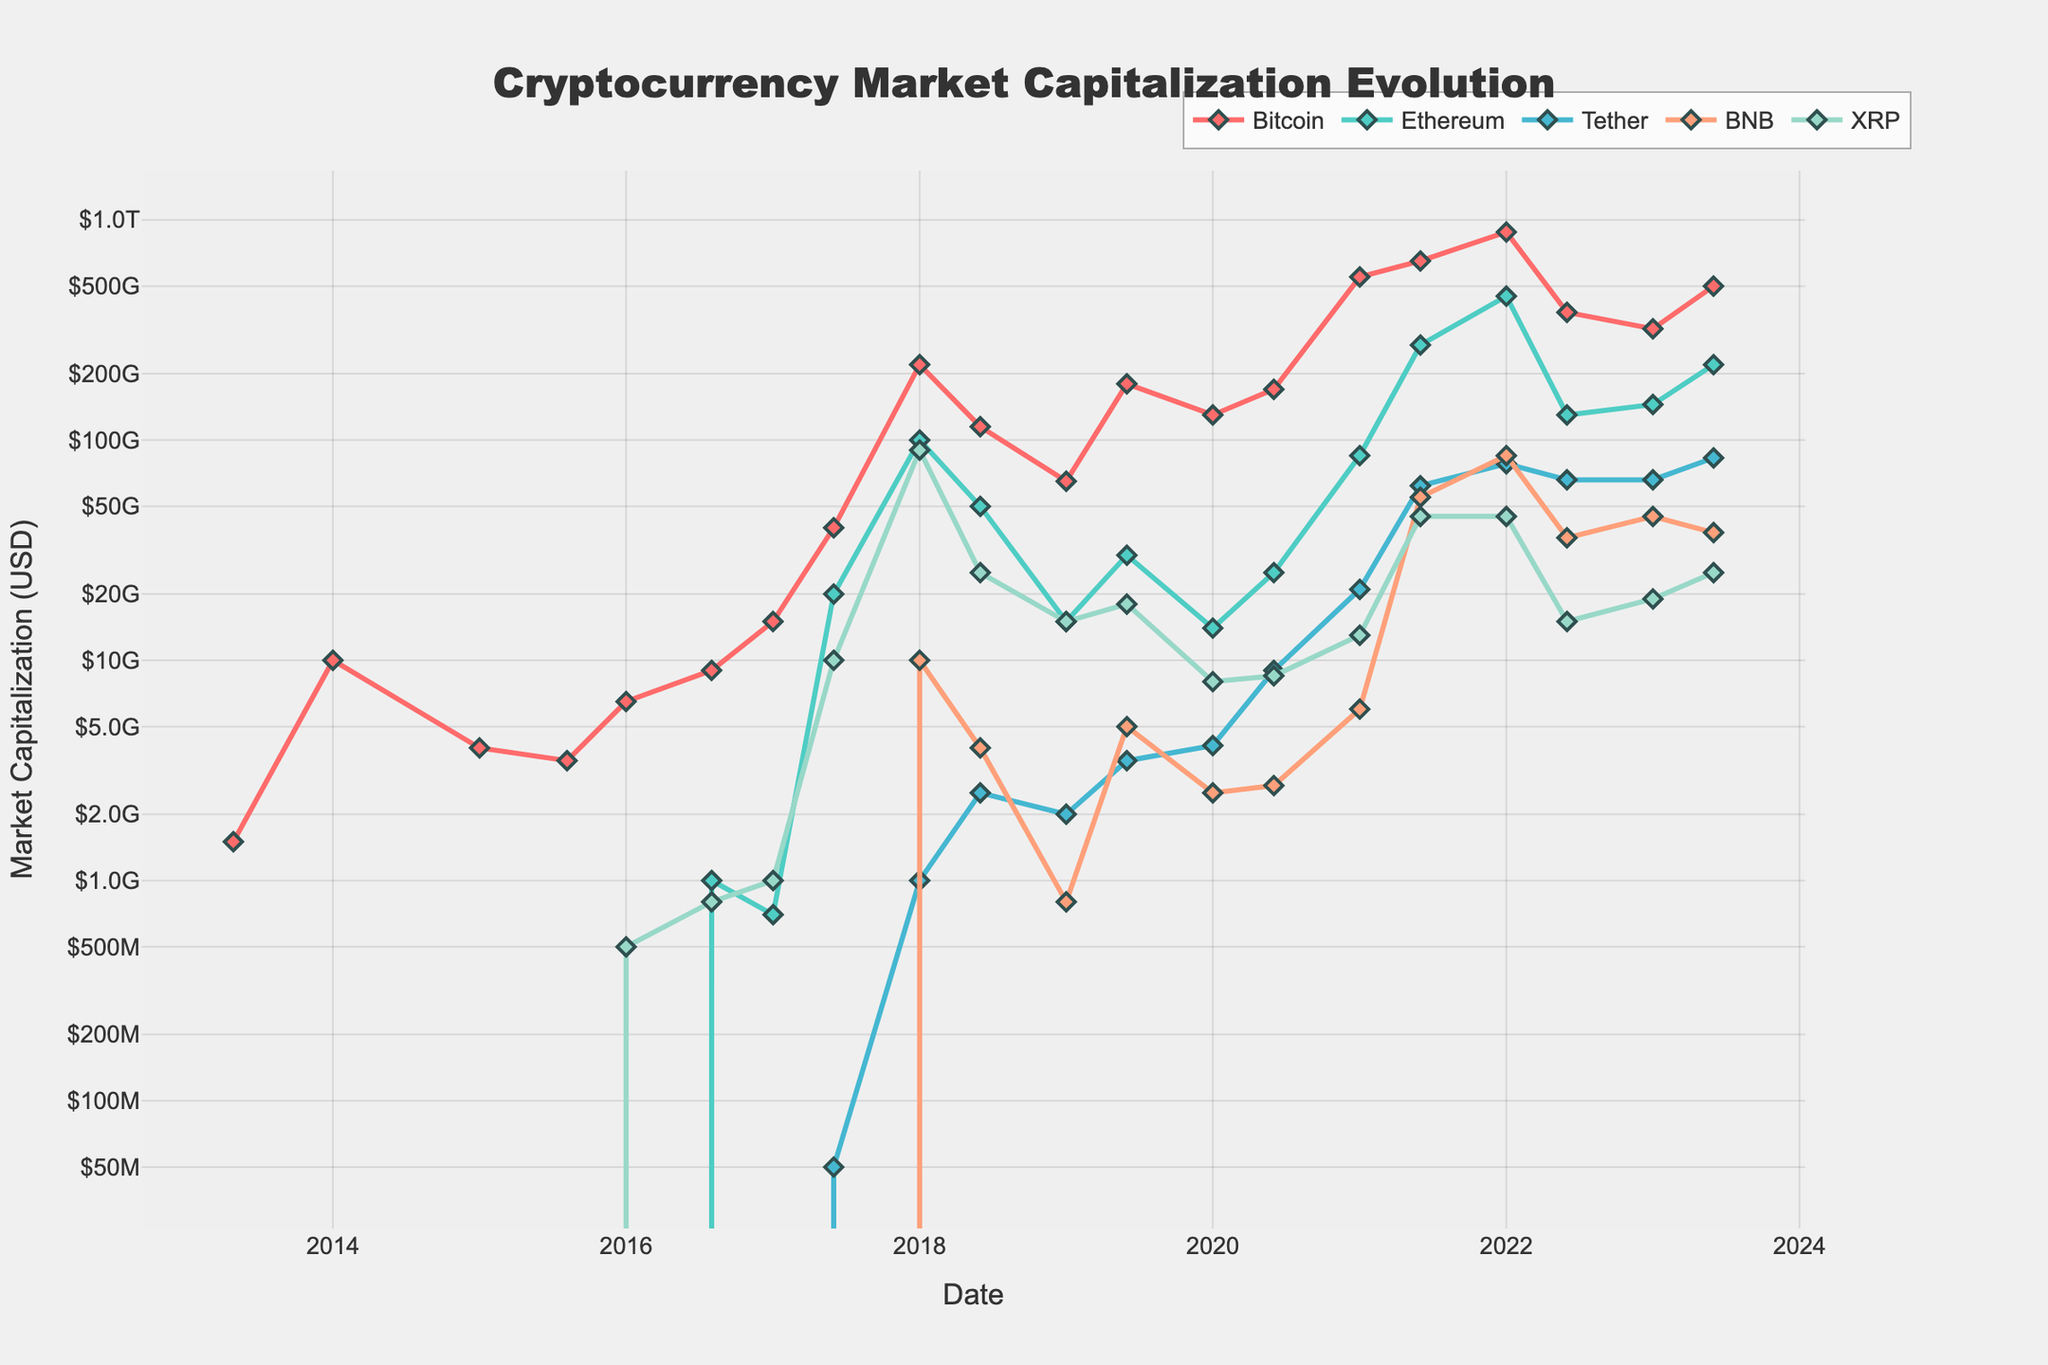Which cryptocurrency had the highest market capitalization on January 1, 2018? By inspecting the plotted lines on the figure for January 1, 2018, and checking the y-axis values, Bitcoin's line reaches the highest point compared to others.
Answer: Bitcoin How did the market capitalization of Tether change from June 2020 to January 2021? Locate the data points for Tether (indicated by its color) in June 2020 and January 2021. Tether's market capitalization increased from about 9 billion USD to 21 billion USD.
Answer: Increased Which two cryptocurrencies showed a significant rise around June 2021? Observe the plots for all cryptocurrencies around June 2021. Both Bitcoin and Ethereum exhibit sharp increases reaching near their peaks, indicating a significant rise.
Answer: Bitcoin and Ethereum Between January 2022 and June 2022, did Ethereum's market capitalization increase or decrease? Look for Ethereum's plot between January 2022 and June 2022 and compare the positions. Ethereum showed a decrease as the line drops significantly.
Answer: Decrease What is the difference in market capitalization between Bitcoin and XRP on January 1, 2018? Find the market capitalizations of Bitcoin and XRP on January 1, 2018, on the vertical axis. Bitcoin is at 220 billion USD, and XRP is at 90 billion USD. The difference is 220 billion - 90 billion = 130 billion USD.
Answer: 130 billion USD Which cryptocurrency has consistently shown growth from its inception up to the latest date? Examine the trends for each cryptocurrency from their start to June 2023. Tether consistently shows growth without major dips, indicating a steady rise.
Answer: Tether By how much did Bitcoin's market capitalization change between January 2022 and June 2022? Locate Bitcoin's data points in January 2022 and June 2022. Bitcoin's market capitalization dropped from 880 billion USD to 380 billion USD. The change is 880 billion - 380 billion = 500 billion USD.
Answer: 500 billion USD Which cryptocurrency exhibited the highest market capitalization in June 2021? Refer to the plotted lines in June 2021 and see which reaches the highest along the y-axis. Bitcoin has the highest market capitalization in that month.
Answer: Bitcoin What is the approximate market capitalization of BNB in January 2021? Identify BNB's plot and locate the data point for January 2021 by checking the y-axis value intersection. BNB's market capitalization is approximately 6 billion USD.
Answer: 6 billion USD Between January 2022 and January 2023, which cryptocurrency experienced the greatest decrease in market capitalization? Compare the plots of all cryptocurrencies from January 2022 to January 2023. Bitcoin showed the greatest decrease, dropping significantly from 880 billion USD to 320 billion USD.
Answer: Bitcoin 